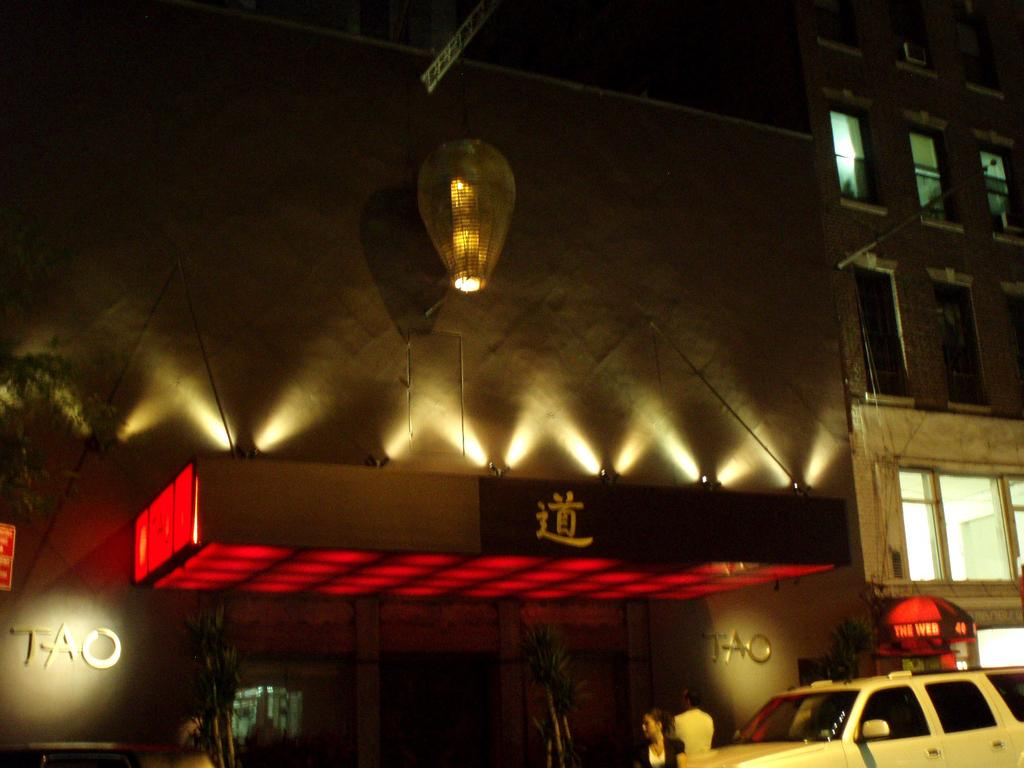<image>
Offer a succinct explanation of the picture presented. The word Tao on a building that is outside 